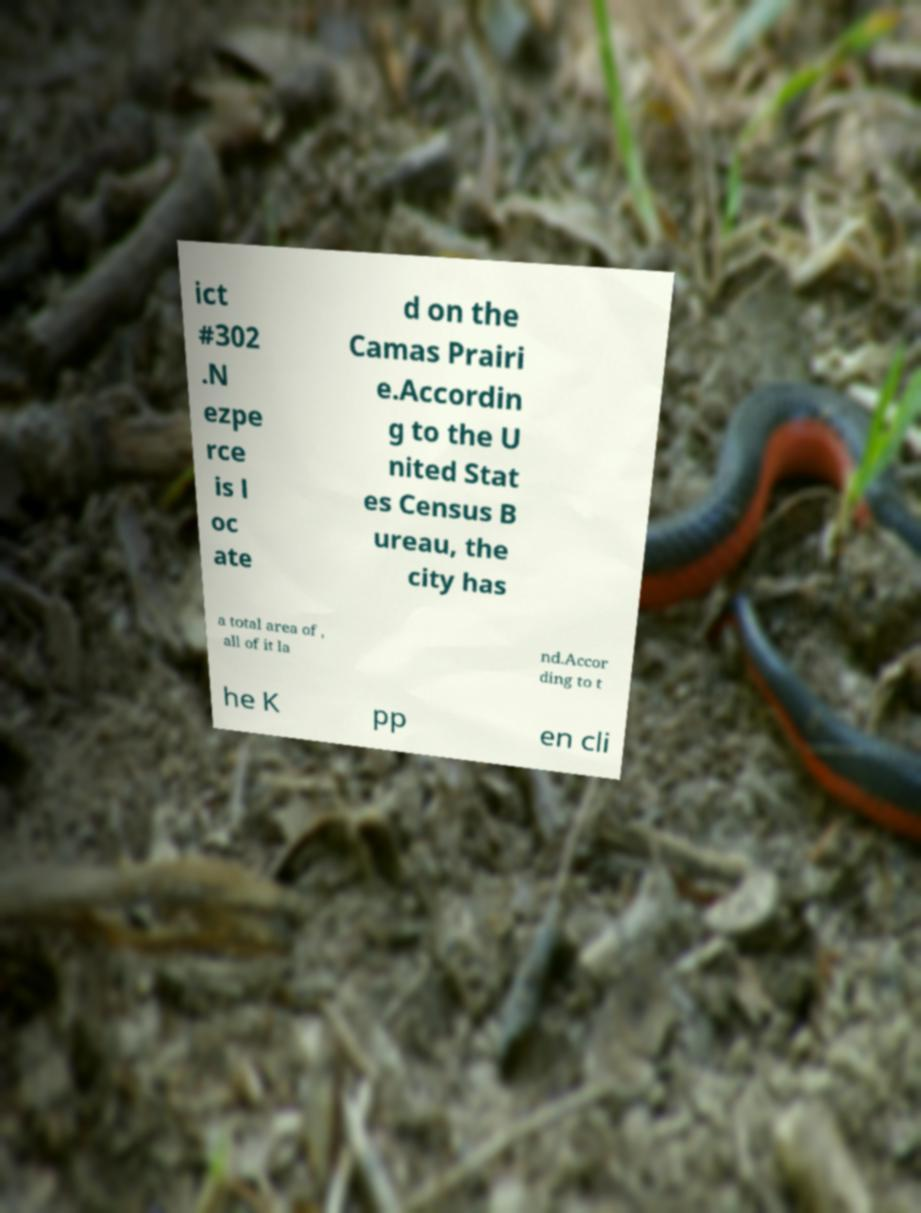Could you assist in decoding the text presented in this image and type it out clearly? ict #302 .N ezpe rce is l oc ate d on the Camas Prairi e.Accordin g to the U nited Stat es Census B ureau, the city has a total area of , all of it la nd.Accor ding to t he K pp en cli 